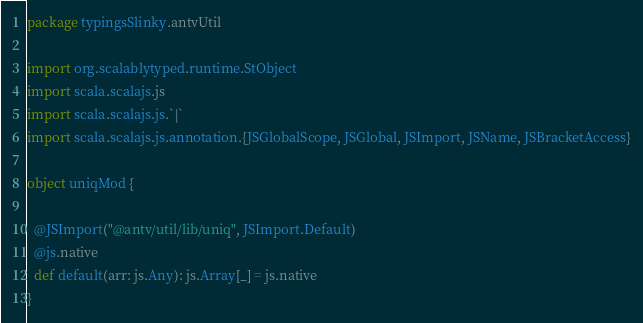Convert code to text. <code><loc_0><loc_0><loc_500><loc_500><_Scala_>package typingsSlinky.antvUtil

import org.scalablytyped.runtime.StObject
import scala.scalajs.js
import scala.scalajs.js.`|`
import scala.scalajs.js.annotation.{JSGlobalScope, JSGlobal, JSImport, JSName, JSBracketAccess}

object uniqMod {
  
  @JSImport("@antv/util/lib/uniq", JSImport.Default)
  @js.native
  def default(arr: js.Any): js.Array[_] = js.native
}
</code> 